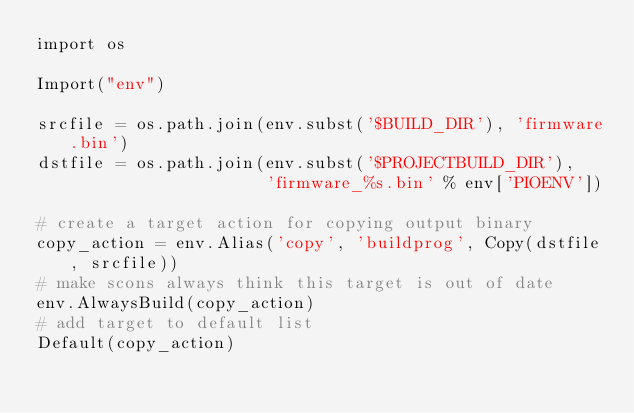Convert code to text. <code><loc_0><loc_0><loc_500><loc_500><_Python_>import os

Import("env")

srcfile = os.path.join(env.subst('$BUILD_DIR'), 'firmware.bin')
dstfile = os.path.join(env.subst('$PROJECTBUILD_DIR'),
                       'firmware_%s.bin' % env['PIOENV'])

# create a target action for copying output binary
copy_action = env.Alias('copy', 'buildprog', Copy(dstfile, srcfile))
# make scons always think this target is out of date
env.AlwaysBuild(copy_action)
# add target to default list
Default(copy_action)
</code> 